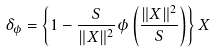Convert formula to latex. <formula><loc_0><loc_0><loc_500><loc_500>\delta _ { \phi } = \left \{ 1 - \frac { S } { \| X \| ^ { 2 } } \phi \left ( \frac { \| X \| ^ { 2 } } { S } \right ) \right \} X</formula> 